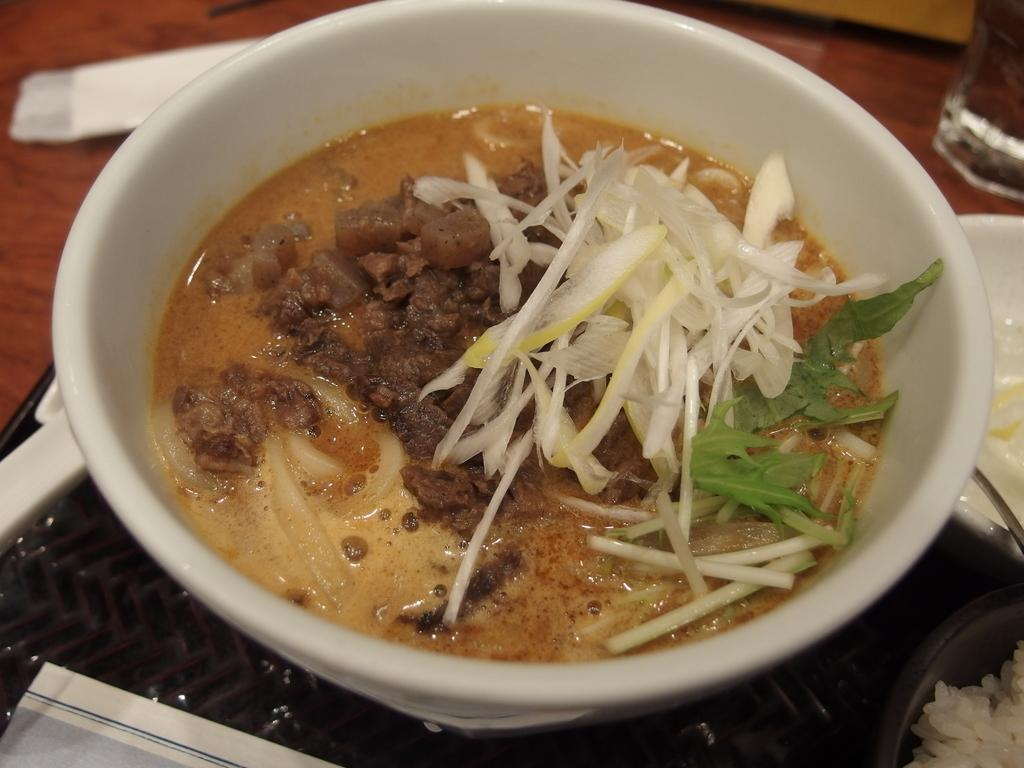What is in the bowl that is visible in the image? There is food in the bowl in the image. What else can be seen in the image besides the bowl? There is a glass visible in the image. What is the tray used for in the image? The tray is on the table in the image, likely for holding or serving food. Is the baby stuck in quicksand in the image? There is no baby or quicksand present in the image. How much dust can be seen on the table in the image? There is no mention of dust in the image, so it cannot be determined how much dust is present. 